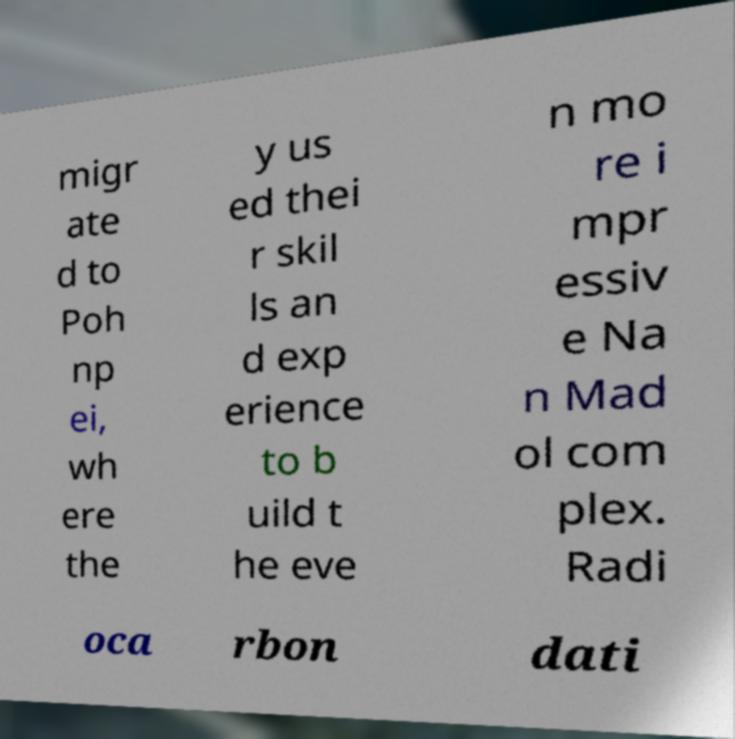Could you assist in decoding the text presented in this image and type it out clearly? migr ate d to Poh np ei, wh ere the y us ed thei r skil ls an d exp erience to b uild t he eve n mo re i mpr essiv e Na n Mad ol com plex. Radi oca rbon dati 